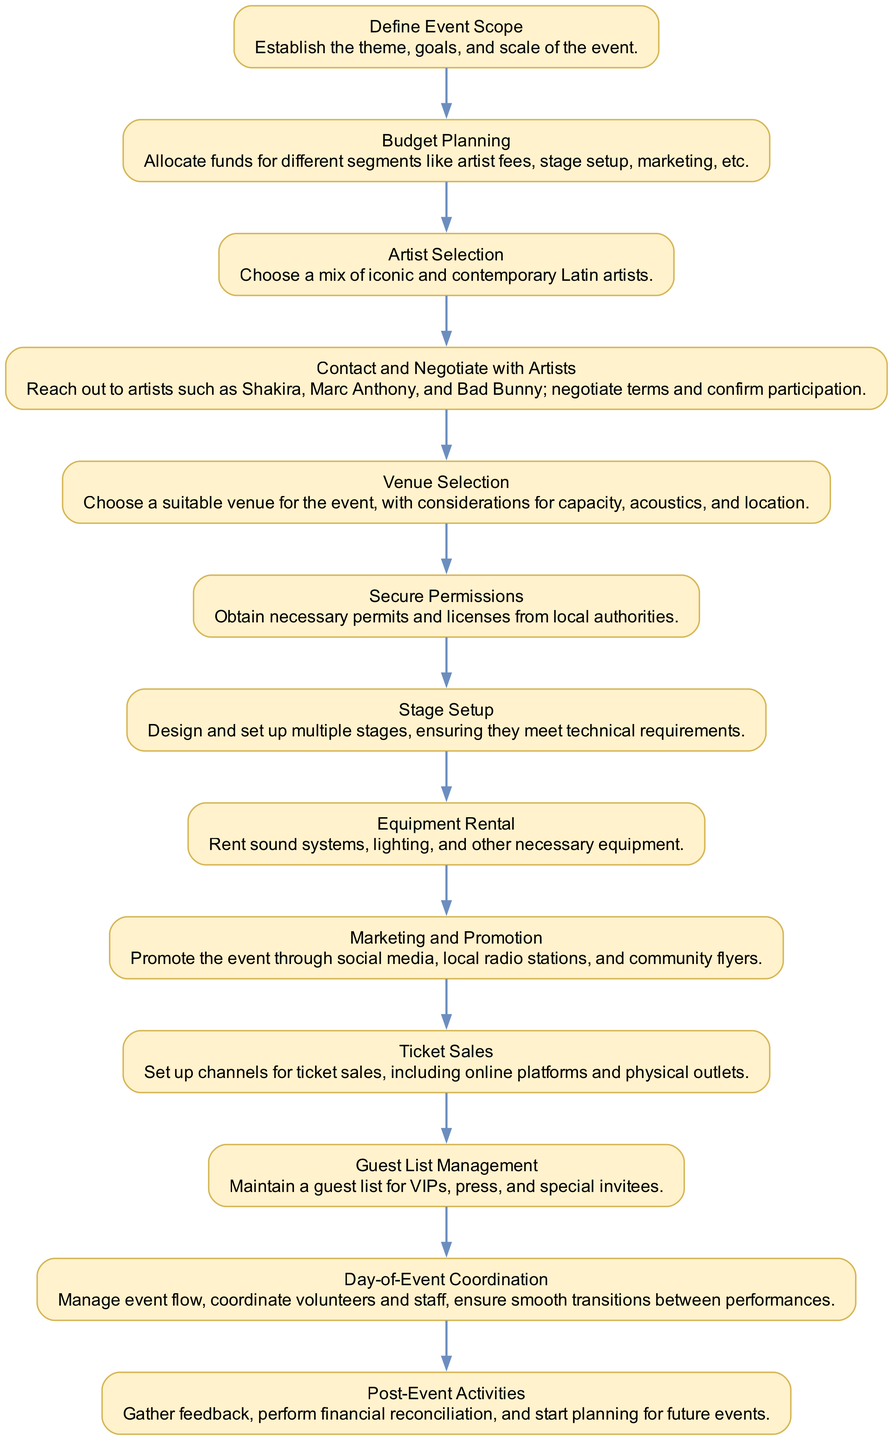What is the first step in the event planning workflow? The diagram shows that the first step is "Define Event Scope," which establishes the theme, goals, and scale of the event. This can be identified as the first node in the flowchart.
Answer: Define Event Scope How many total steps are in the workflow? By counting the nodes in the diagram, we find there are 13 steps listed in sequence, each representing a distinct part of the workflow.
Answer: 13 What is the last step of the workflow? The diagram indicates the last step is "Post-Event Activities," which focuses on gathering feedback and planning for future events, found at the end of the sequence.
Answer: Post-Event Activities Which step involves negotiating terms with artists? The diagram clearly labels "Contact and Negotiate with Artists" as the step where terms are negotiated, and it falls between artist selection and venue selection.
Answer: Contact and Negotiate with Artists What action occurs after artist selection? The diagram illustrates that "Contact and Negotiate with Artists" follows "Artist Selection," as these are consecutive steps in the workflow.
Answer: Contact and Negotiate with Artists What is the connection between stage setup and equipment rental? The diagram shows that "Stage Setup" comes before "Equipment Rental," highlighting that equipment must be arranged after stages are designed.
Answer: Stage Setup Which step ensures legal compliance for the event? The diagram specifies "Secure Permissions" as the step responsible for obtaining necessary permits and licenses, ensuring that the event is legally compliant.
Answer: Secure Permissions How is marketing approached in the workflow? The diagram indicates "Marketing and Promotion" as a dedicated step, suggesting it is a strategic activity carried out after budgeting and artist selection.
Answer: Marketing and Promotion What is the primary focus of the step titled "Day-of-Event Coordination"? According to the diagram, "Day-of-Event Coordination" is concentrated on managing the event's flow, coordinating volunteers, and ensuring smooth transitions.
Answer: Managing event flow What precedes the ticket sales in the planning process? The diagram indicates that "Marketing and Promotion" happens before "Ticket Sales," emphasizing that promoting the event is crucial before selling tickets.
Answer: Marketing and Promotion 